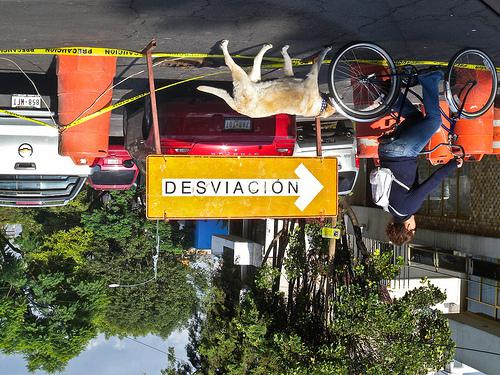Question: what type of animal is in this picture?
Choices:
A. Cat.
B. Lion.
C. Dog.
D. Tiger.
Answer with the letter. Answer: C Question: where is the backpack?
Choices:
A. On person's back.
B. On the chair.
C. On the sofa.
D. On the bed.
Answer with the letter. Answer: A Question: what type of pants is the person wearing?
Choices:
A. Khakis.
B. Jeans.
C. Cargo pants.
D. Slacks.
Answer with the letter. Answer: B 